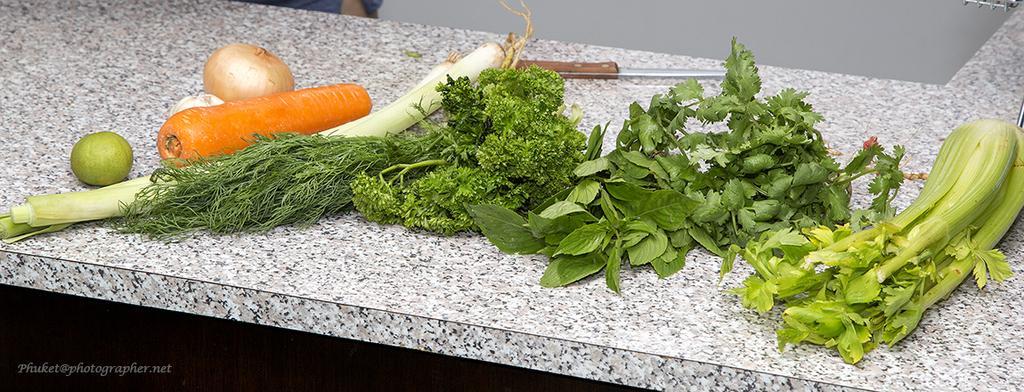Describe this image in one or two sentences. In this picture I can see vegetables and a knife on the table, and there is a watermark on the image. 